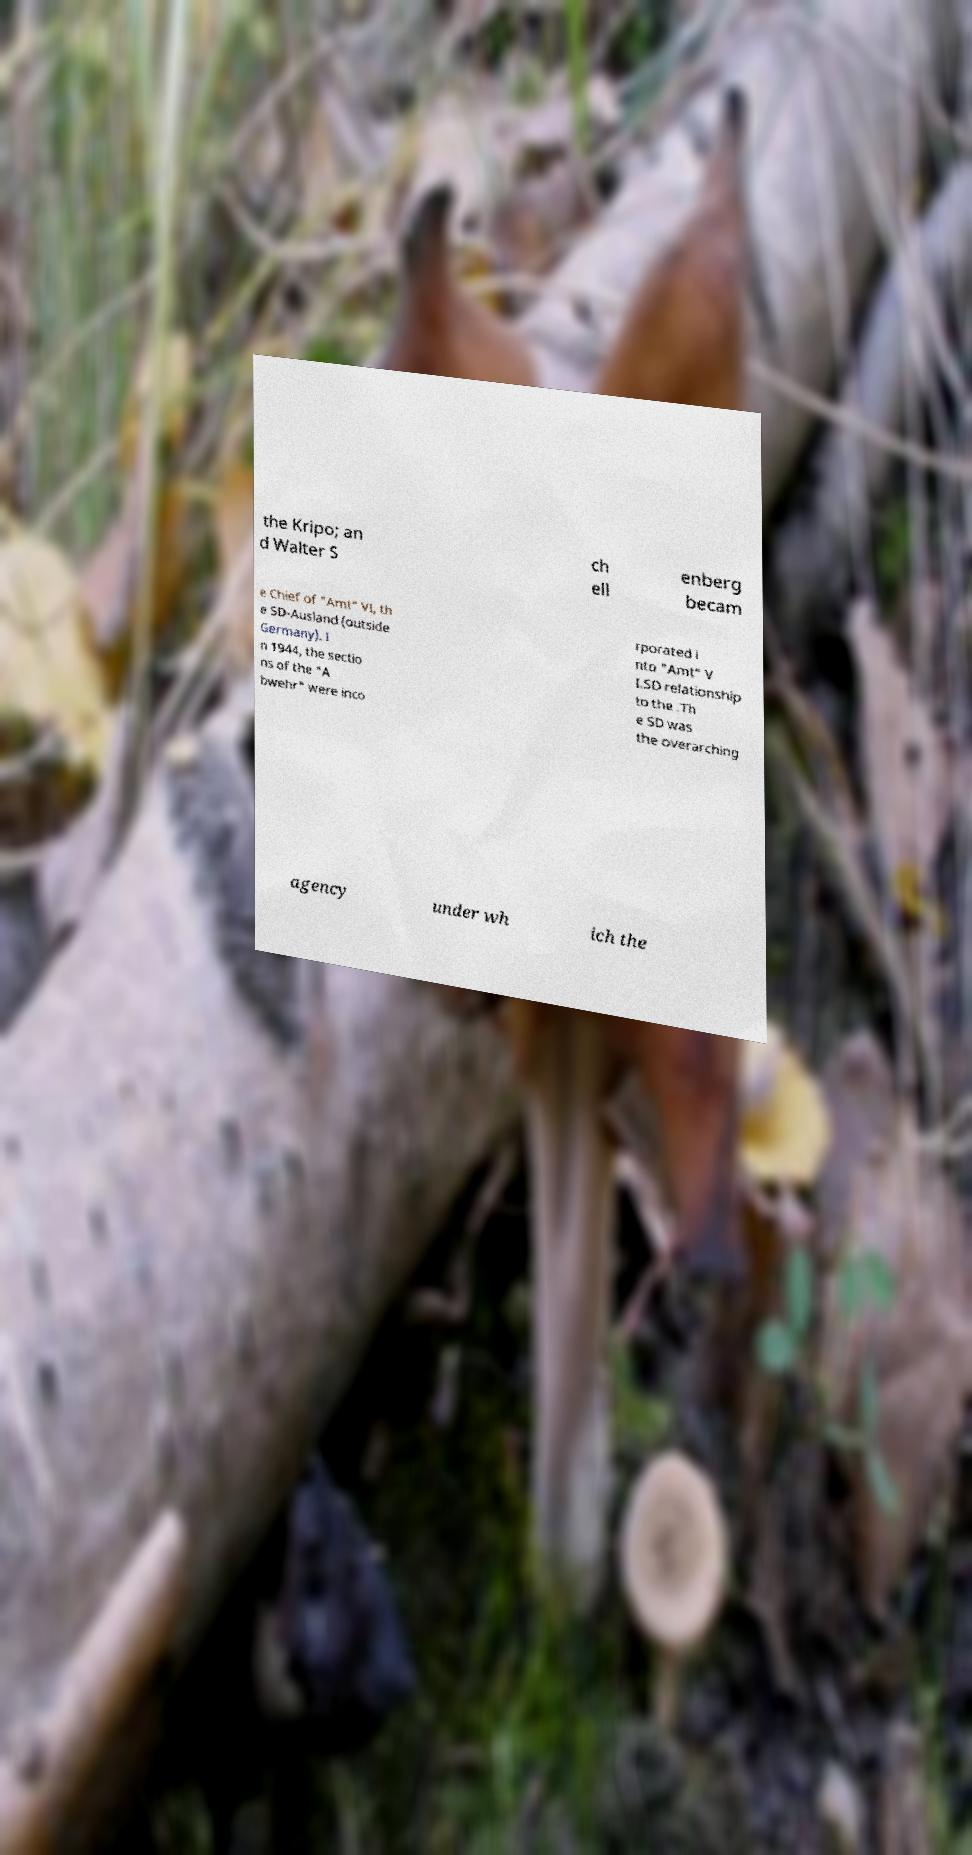Can you read and provide the text displayed in the image?This photo seems to have some interesting text. Can you extract and type it out for me? the Kripo; an d Walter S ch ell enberg becam e Chief of "Amt" VI, th e SD-Ausland (outside Germany). I n 1944, the sectio ns of the "A bwehr" were inco rporated i nto "Amt" V I.SD relationship to the .Th e SD was the overarching agency under wh ich the 